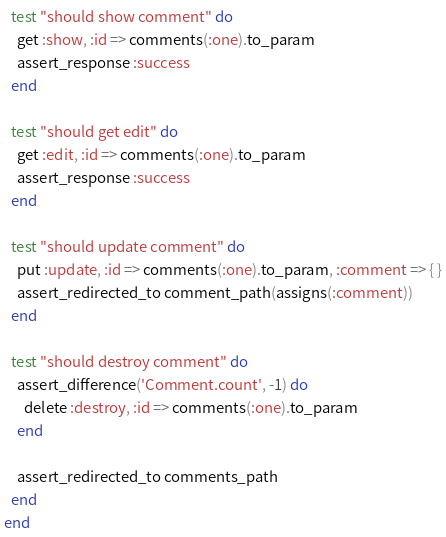<code> <loc_0><loc_0><loc_500><loc_500><_Ruby_>  test "should show comment" do
    get :show, :id => comments(:one).to_param
    assert_response :success
  end

  test "should get edit" do
    get :edit, :id => comments(:one).to_param
    assert_response :success
  end

  test "should update comment" do
    put :update, :id => comments(:one).to_param, :comment => { }
    assert_redirected_to comment_path(assigns(:comment))
  end

  test "should destroy comment" do
    assert_difference('Comment.count', -1) do
      delete :destroy, :id => comments(:one).to_param
    end

    assert_redirected_to comments_path
  end
end
</code> 